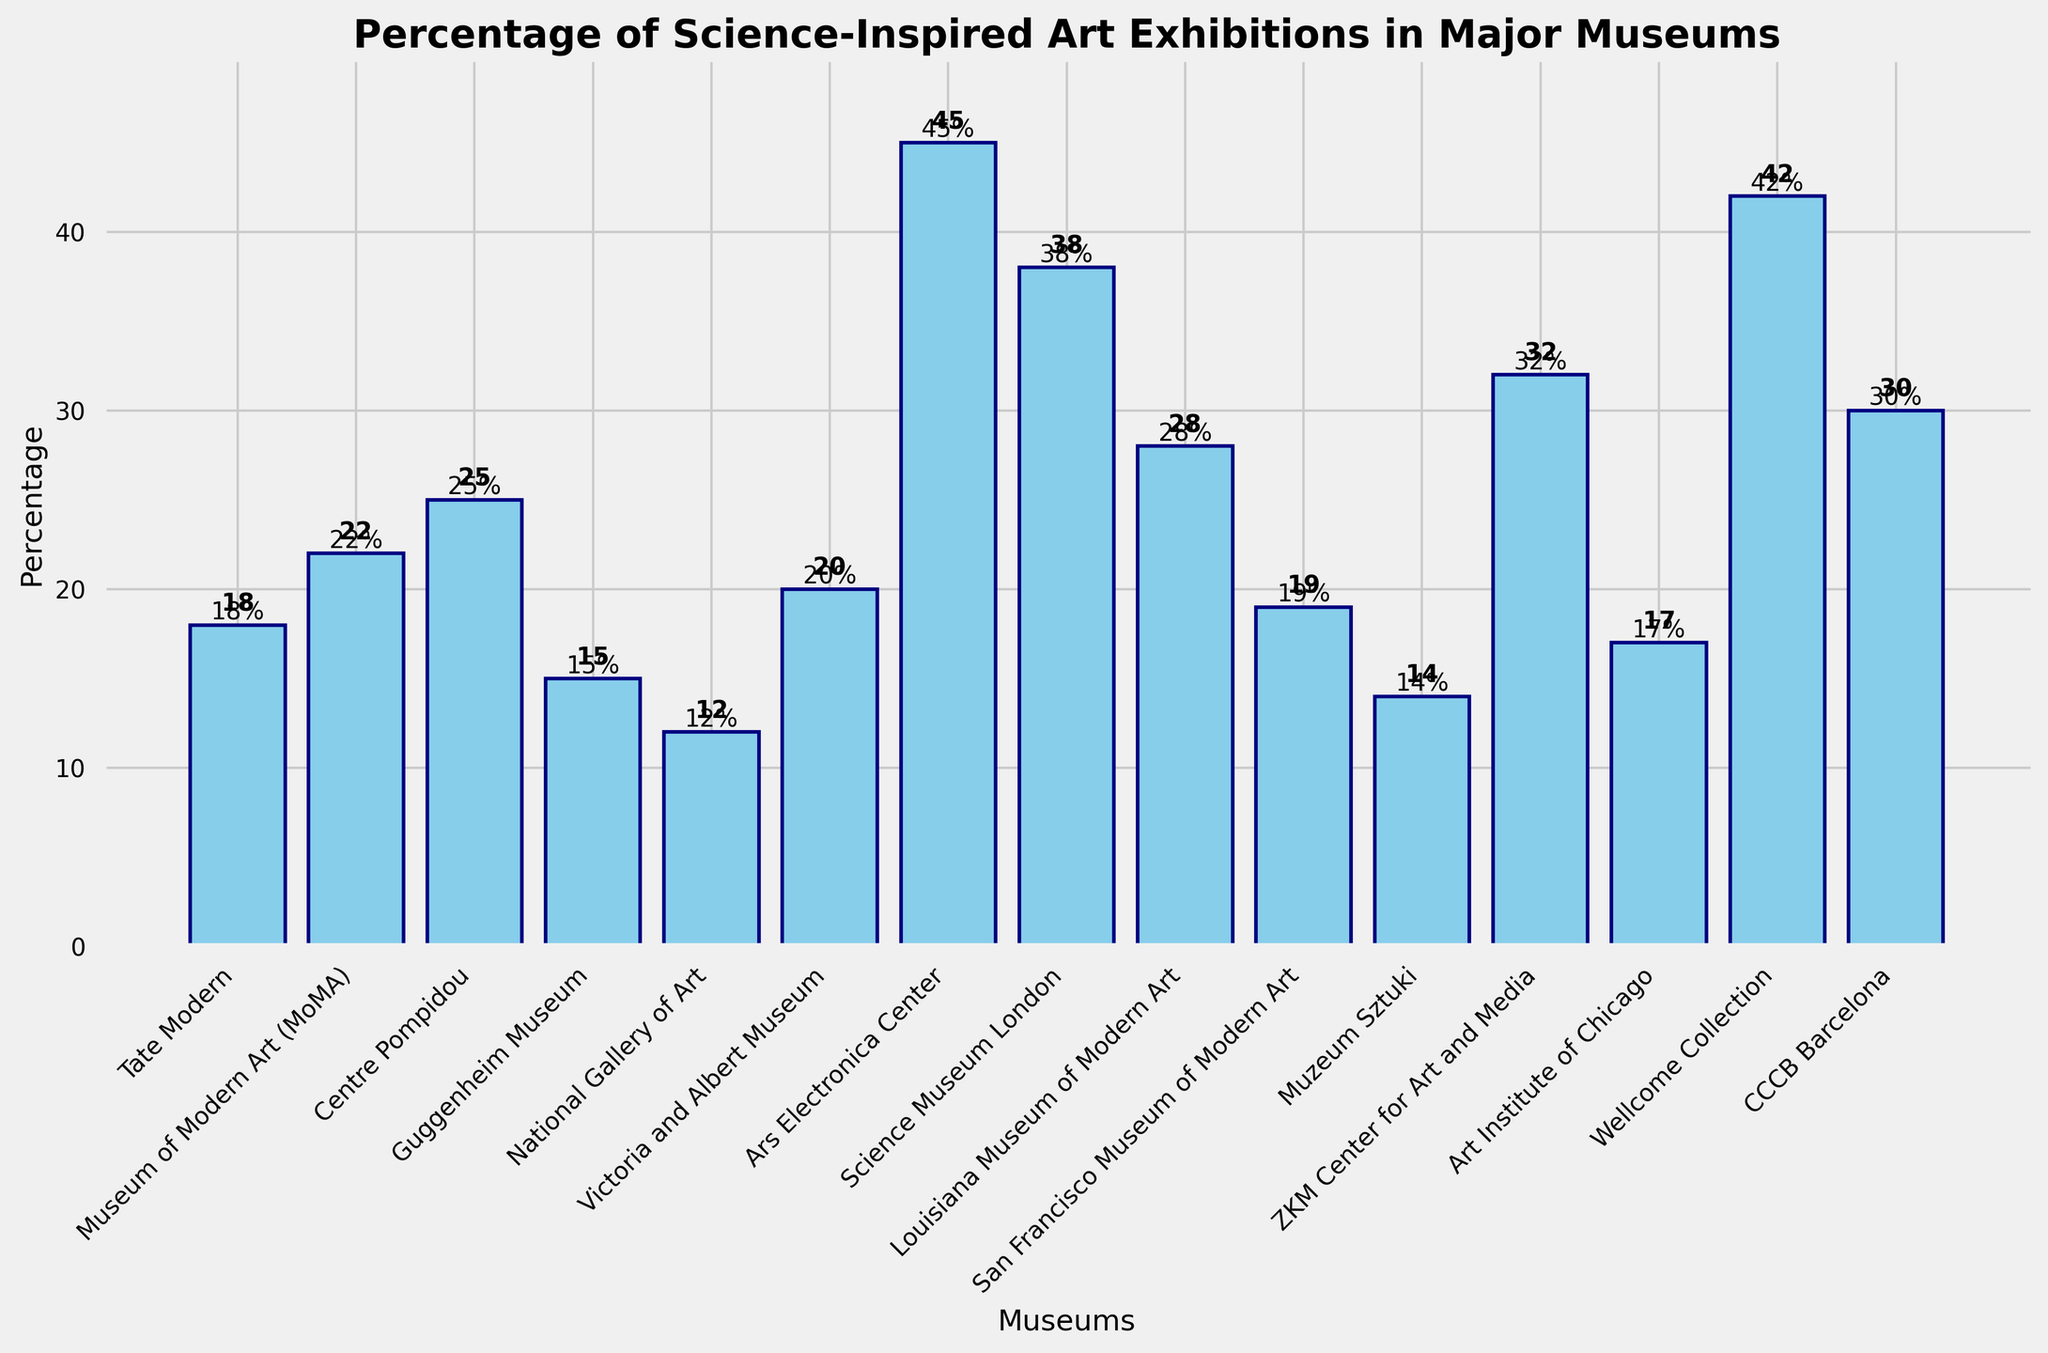Which museum has the highest percentage of science-inspired art exhibitions? The bar chart shows different museums and their respective percentages of science-inspired art exhibitions. The highest bar represents the highest percentage, which is for the Ars Electronica Center at 45%.
Answer: Ars Electronica Center Which museum has the lowest percentage of science-inspired art exhibitions? By observing the bar chart, the smallest bar corresponds to the National Gallery of Art, with a percentage of 12%.
Answer: National Gallery of Art Which two museums have the closest percentages of science-inspired art exhibitions? By comparing the heights of the bars visually, the San Francisco Museum of Modern Art and the Tate Modern have very close percentages, at 19% and 18% respectively.
Answer: San Francisco Museum of Modern Art and Tate Modern What's the average percentage of science-inspired art exhibitions across all the museums? Sum all the percentages and divide by the number of museums. The percentages are (18 + 22 + 25 + 15 + 12 + 20 + 45 + 38 + 28 + 19 + 14 + 32 + 17 + 42 + 30) = 377, and there are 15 museums. So, the average is 377 / 15 ≈ 25.13%.
Answer: 25.13% Which museums have percentages higher than 35%? Scanning the chart, the bars that extend beyond the 35% mark represent the Ars Electronica Center (45%), Science Museum London (38%), and Wellcome Collection (42%).
Answer: Ars Electronica Center, Science Museum London, and Wellcome Collection What is the median percentage of science-inspired art exhibitions among these museums? Arrange the percentages in ascending order: 12, 14, 15, 17, 18, 19, 20, 22, 25, 28, 30, 32, 38, 42, 45. The middle value (8th in the list) is 22.
Answer: 22 How much more is the percentage of science-inspired art exhibitions in the Wellcome Collection compared to the National Gallery of Art? Subtract the National Gallery of Art's percentage (12%) from the Wellcome Collection's percentage (42%): 42 - 12 = 30%.
Answer: 30% What is the combined percentage of science-inspired art exhibitions for Centre Pompidou and CCCB Barcelona? Add the percentages for Centre Pompidou (25%) and CCCB Barcelona (30%): 25 + 30 = 55%.
Answer: 55% Which museum has a percentage closest to the overall average percentage of 25.13%? Compare the museums' percentages to the average: 18, 22, 25, 15, 12, 20, 45, 38, 28, 19, 14, 32, 17, 42, 30. The Centre Pompidou, with 25%, is closest to 25.13%.
Answer: Centre Pompidou 